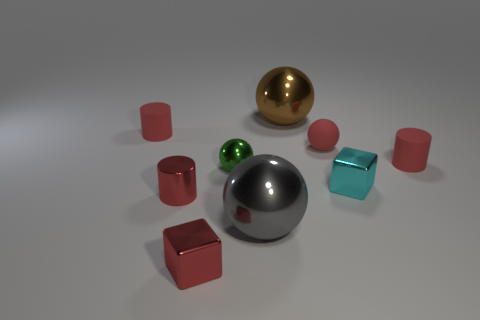Subtract 1 balls. How many balls are left? 3 Add 1 large metallic balls. How many objects exist? 10 Subtract all cubes. How many objects are left? 7 Add 2 cyan shiny blocks. How many cyan shiny blocks exist? 3 Subtract 1 cyan cubes. How many objects are left? 8 Subtract all cyan metallic cubes. Subtract all big red shiny objects. How many objects are left? 8 Add 4 big brown balls. How many big brown balls are left? 5 